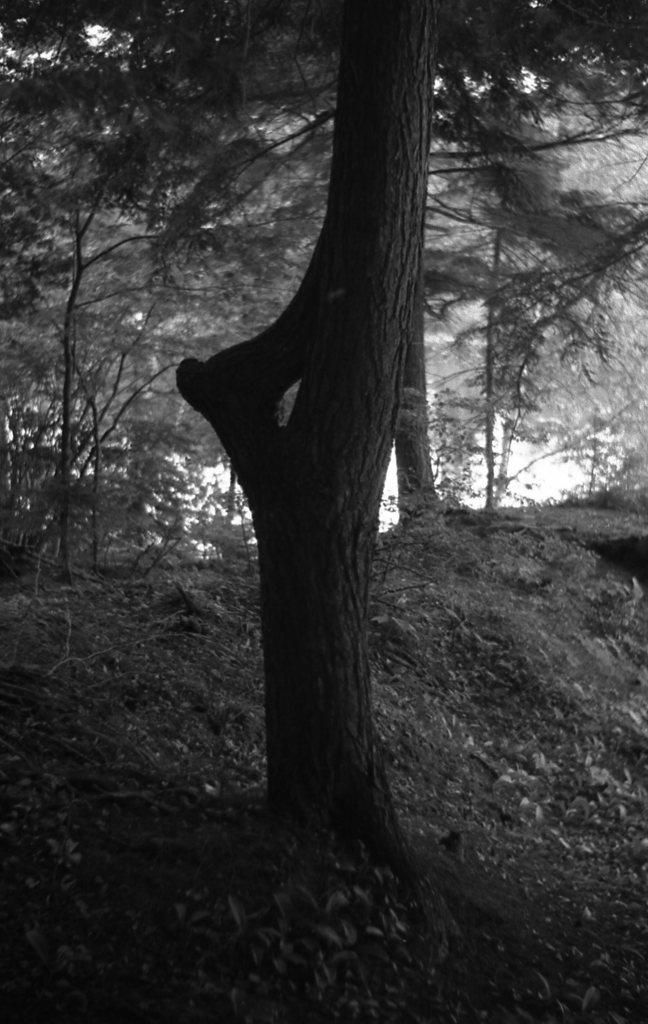What is the color scheme of the image? The image is black and white. What type of landscape is depicted in the image? There are many trees visible on the ground in the image. What type of drink is being served in the image? There is no drink visible in the image; it only features trees on the ground. What type of page is shown in the image? There is no page present in the image; it is a black and white landscape with trees. 